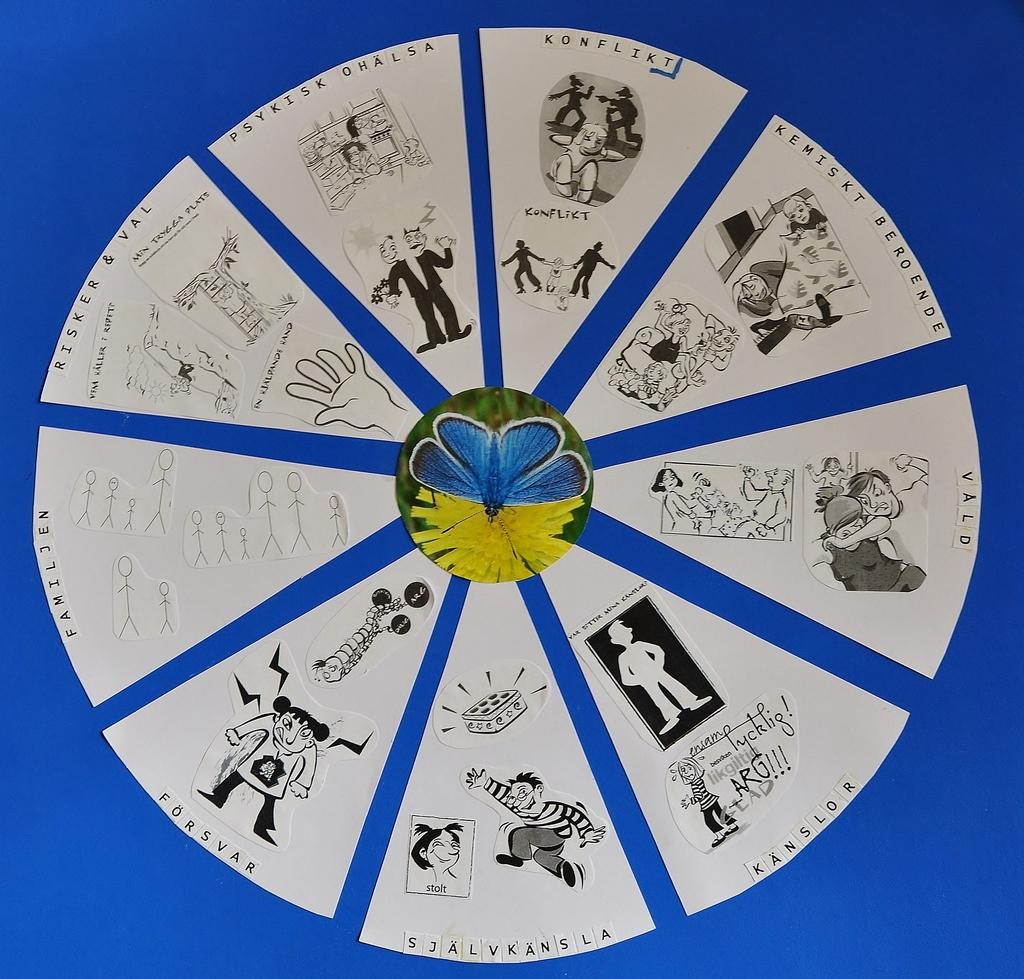What color is the object that has papers on it in the image? The object is blue. What is on the blue object in the image? There are papers on the blue object. What can be seen on the papers in the image? The papers have stickers and drawings on them. Can you see a girl holding a bat and a whip in the image? There is no girl, bat, or whip present in the image. 